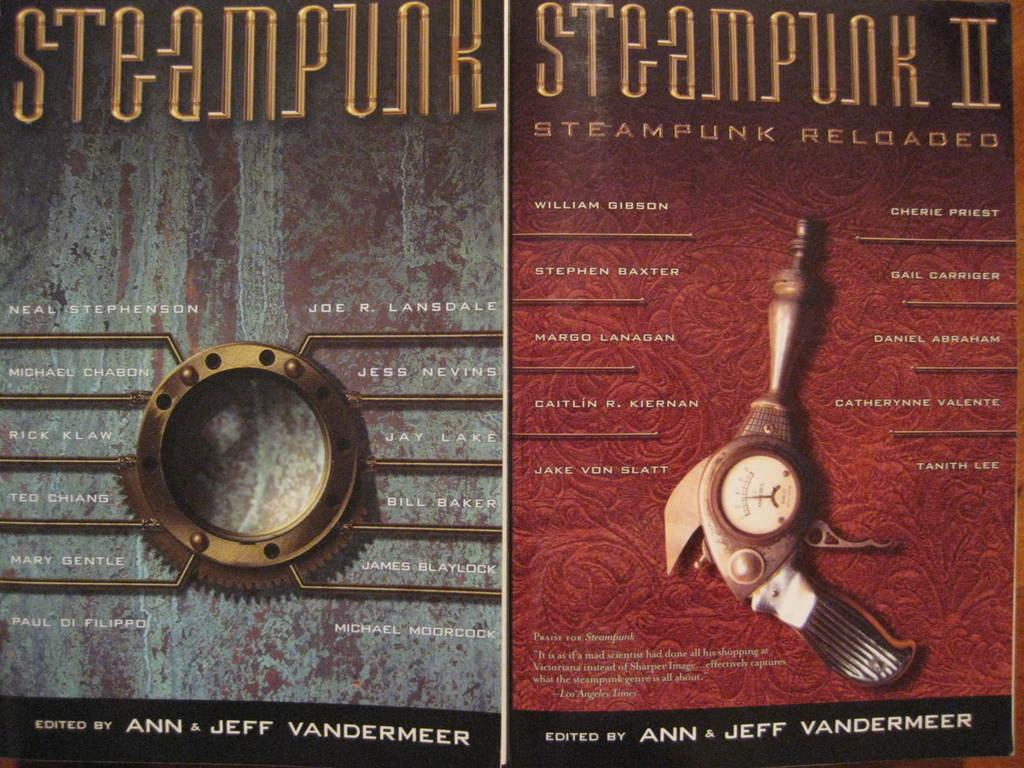<image>
Share a concise interpretation of the image provided. A poster promoting Steampunk and Steampunk 2 both edited by Ann & Jeff Vandermeer. 